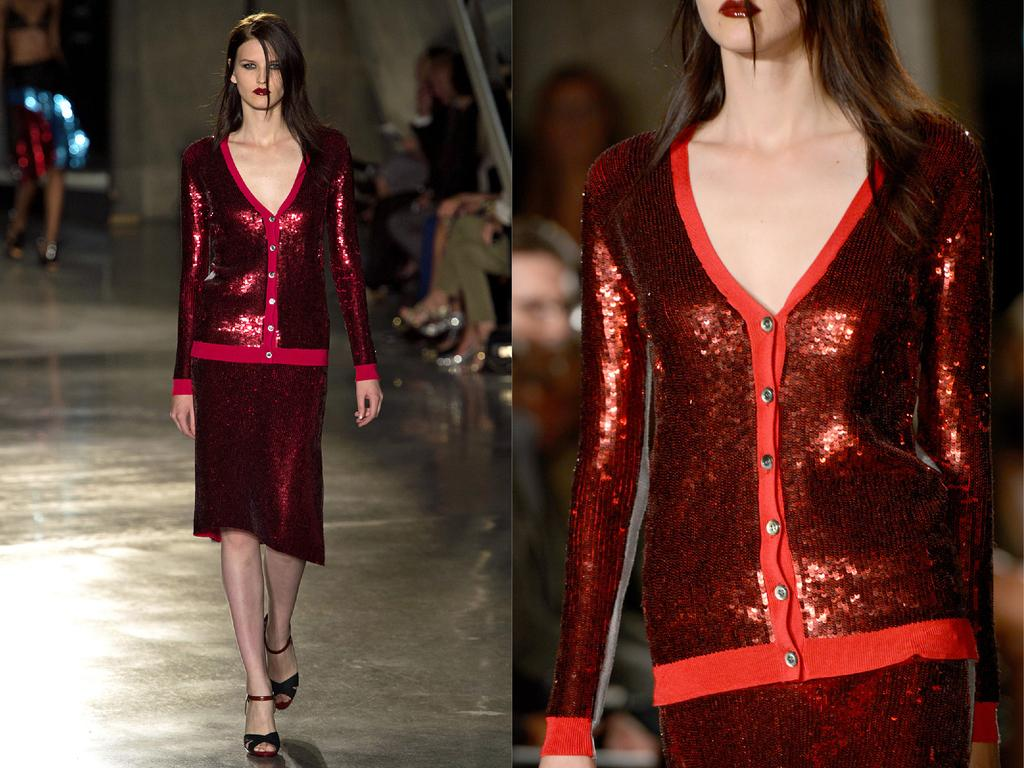What is the main subject of the image? The main subject of the image is a person. How many pictures of the person are in the image? The image is a collage of two similar pictures of the same person. What can be observed about the person's attire in the image? The person in the image is wearing clothes. What type of store can be seen in the background of the image? There is no store visible in the image; it is a collage of two pictures of the same person wearing clothes. On which side of the person is the store located in the image? As mentioned earlier, there is no store present in the image. 